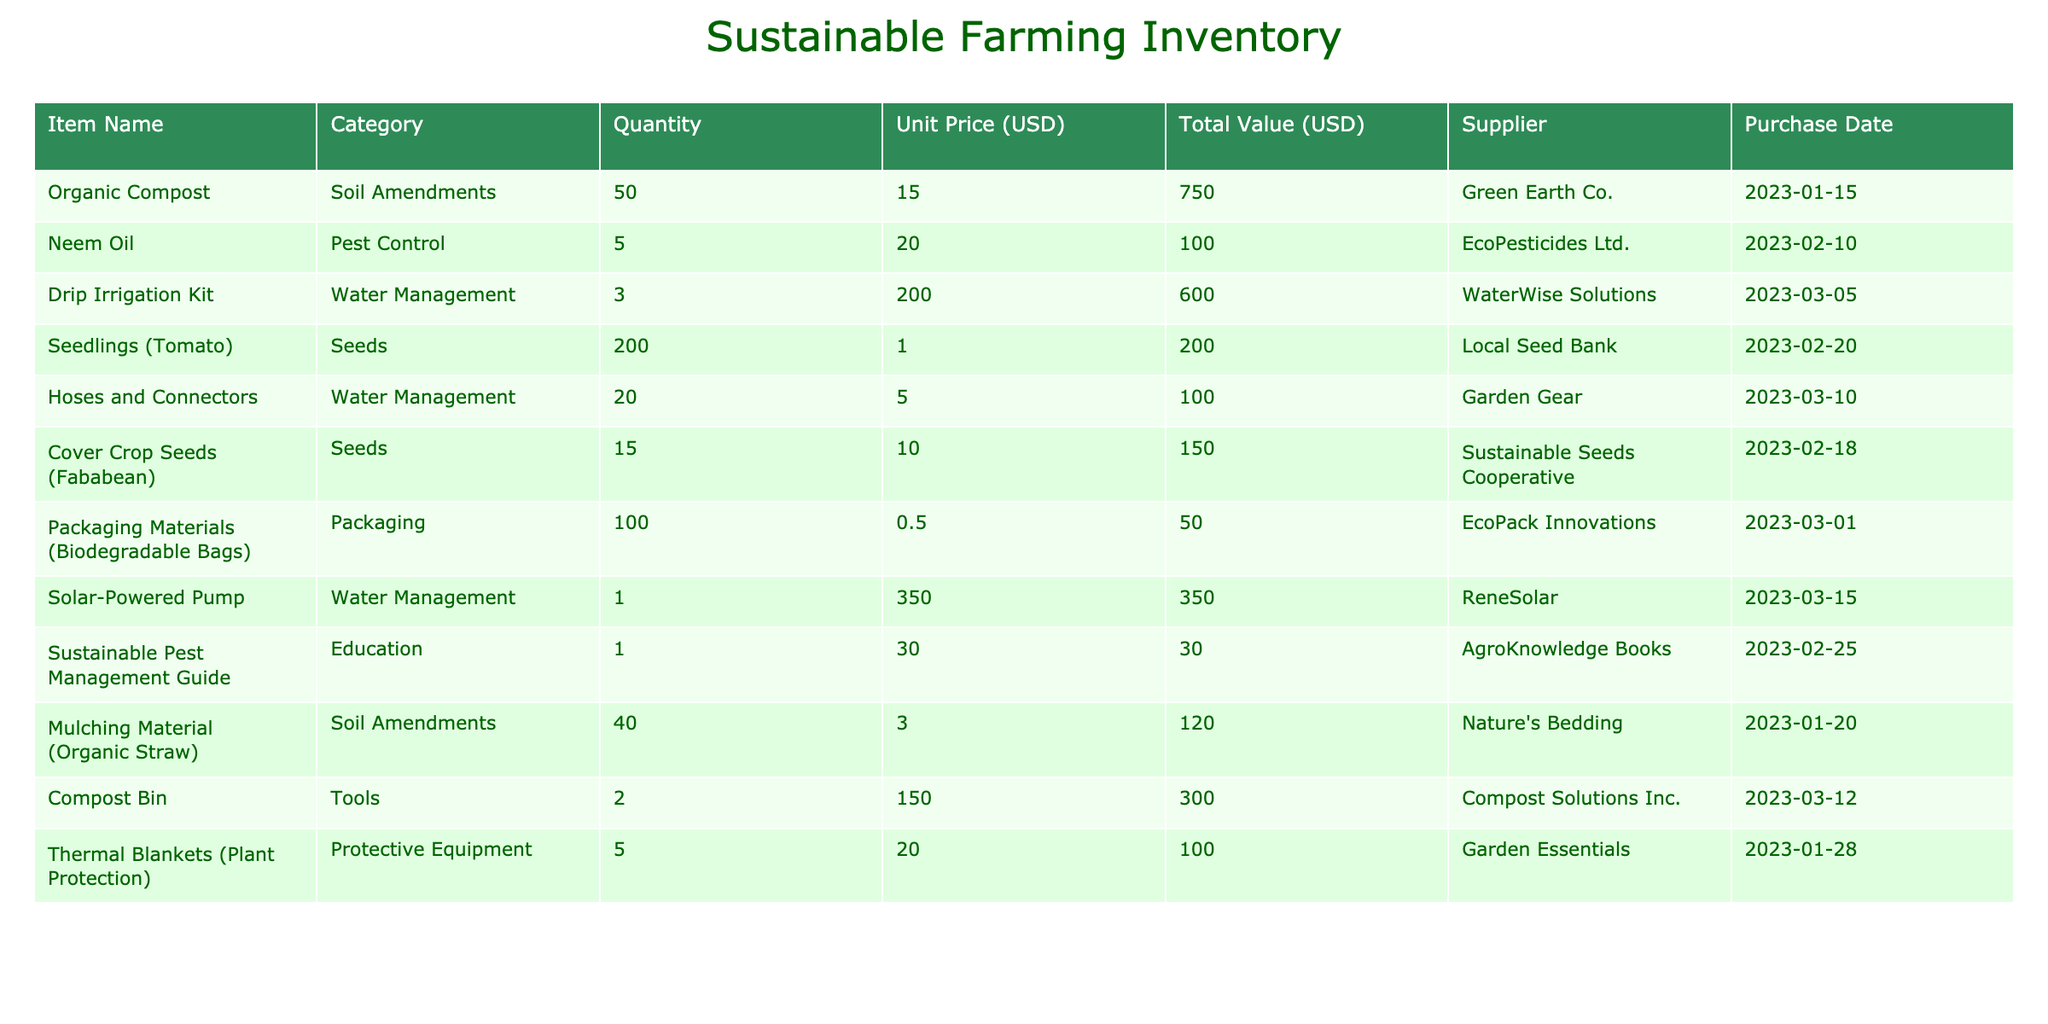What is the total value of all items in the inventory? To find the total value, sum up the 'Total Value (USD)' column: 750 + 100 + 600 + 200 + 100 + 150 + 50 + 350 + 30 + 120 + 300 + 100 = 2450.
Answer: 2450 How many units of Neem Oil are available? The table shows the 'Quantity' for Neem Oil as 5 units.
Answer: 5 What is the average unit price of Seeds in the inventory? The unit prices for Seeds are 1 (Seedlings Tomato) and 10 (Cover Crop Seeds Fababean). The average is calculated as (1 + 10) / 2 = 5.5.
Answer: 5.5 Is there any item that has more than 50 units available? By reviewing the 'Quantity' column, Organic Compost has 50 units, which is not more than 50. All other items have less than 50 units. Therefore, the answer is no.
Answer: No What is the total quantity of Water Management supplies? The items in the Water Management category are the Drip Irrigation Kit (3 units), Hoses and Connectors (20 units), and Solar-Powered Pump (1 unit). The total quantity is 3 + 20 + 1 = 24 units.
Answer: 24 Which supplier provided the most items? Checking the 'Quantity' from each supplier: Green Earth Co. (50), EcoPesticides Ltd. (5), WaterWise Solutions (3), Local Seed Bank (200), Sustainable Seeds Cooperative (15), EcoPack Innovations (100), ReneSolar (1), AgroKnowledge Books (1), Nature's Bedding (40), Compost Solutions Inc. (2), and Garden Essentials (5). Local Seed Bank provided the most with 200 units.
Answer: Local Seed Bank How much did the Packaging Materials cost per unit? The 'Unit Price (USD)' for Packaging Materials (Biodegradable Bags) is listed as 0.5 USD.
Answer: 0.5 What is the difference in total value between Soil Amendments and Pest Control supplies? Total value for Soil Amendments is Organic Compost (750) + Mulching Material (120) = 870. For Pest Control, the total value is Neem Oil (100). The difference is 870 - 100 = 770.
Answer: 770 Are there more tools or protective equipment items in the inventory? The tools section includes Compost Bin (2 units), and the protective equipment section has Thermal Blankets (5 units). There are 1 item in tools and 1 item in protective equipment, so the counts are equal.
Answer: Equal 